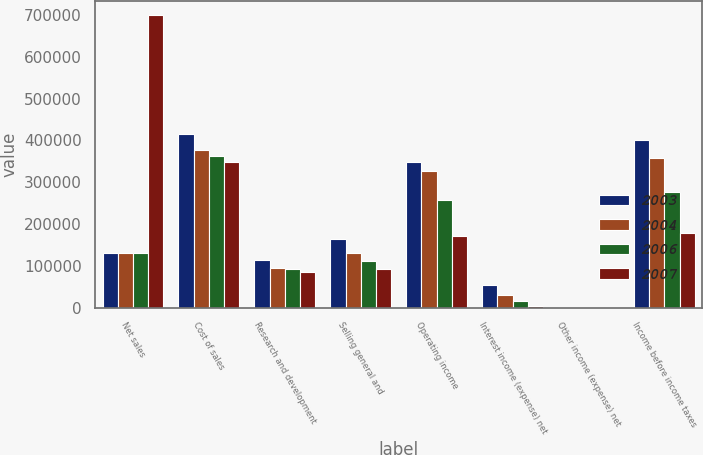Convert chart. <chart><loc_0><loc_0><loc_500><loc_500><stacked_bar_chart><ecel><fcel>Net sales<fcel>Cost of sales<fcel>Research and development<fcel>Selling general and<fcel>Operating income<fcel>Interest income (expense) net<fcel>Other income (expense) net<fcel>Income before income taxes<nl><fcel>2003<fcel>129587<fcel>414915<fcel>113698<fcel>163247<fcel>347811<fcel>52967<fcel>312<fcel>401090<nl><fcel>2004<fcel>129587<fcel>377016<fcel>94926<fcel>129587<fcel>326364<fcel>30786<fcel>2035<fcel>359185<nl><fcel>2006<fcel>129587<fcel>362961<fcel>93040<fcel>111188<fcel>258647<fcel>16864<fcel>1757<fcel>277268<nl><fcel>2007<fcel>699260<fcel>349301<fcel>85389<fcel>92411<fcel>171294<fcel>4639<fcel>1963<fcel>177896<nl></chart> 